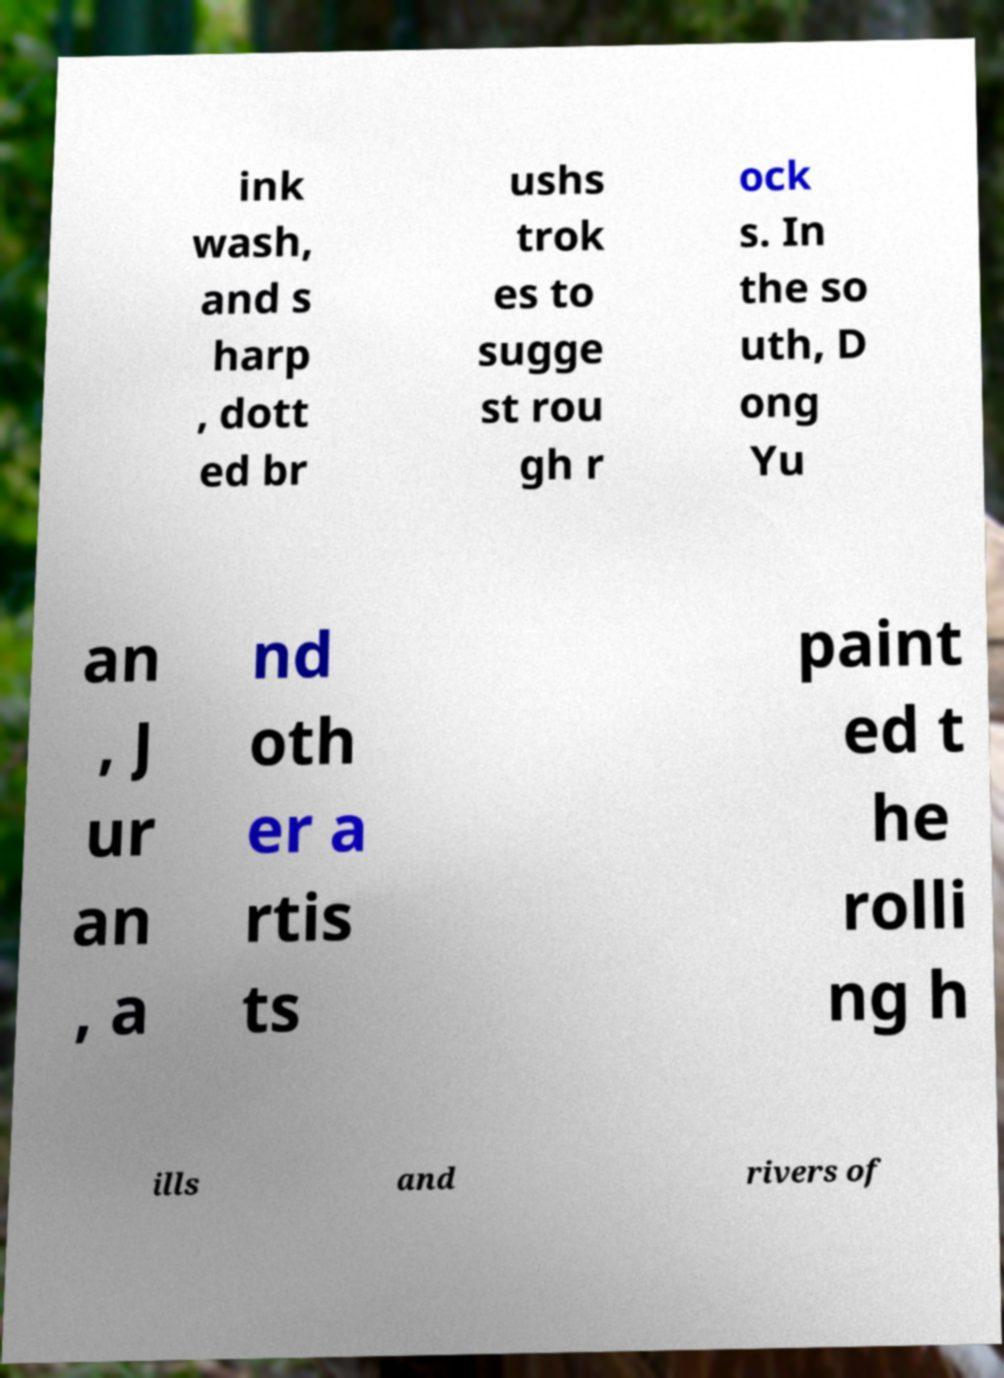Could you assist in decoding the text presented in this image and type it out clearly? ink wash, and s harp , dott ed br ushs trok es to sugge st rou gh r ock s. In the so uth, D ong Yu an , J ur an , a nd oth er a rtis ts paint ed t he rolli ng h ills and rivers of 